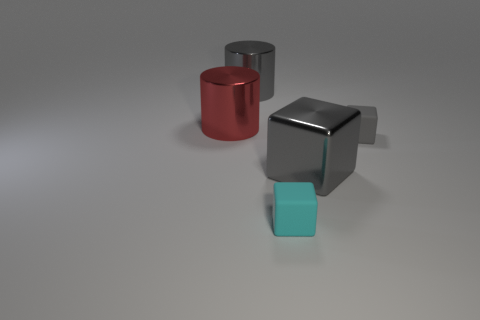Subtract all gray metal cubes. How many cubes are left? 2 Subtract all cyan cubes. How many cubes are left? 2 Subtract all blocks. How many objects are left? 2 Subtract 1 cylinders. How many cylinders are left? 1 Add 1 small cyan matte things. How many objects exist? 6 Subtract all green cubes. How many red cylinders are left? 1 Add 3 red metallic cylinders. How many red metallic cylinders exist? 4 Subtract 0 green cubes. How many objects are left? 5 Subtract all purple cylinders. Subtract all gray balls. How many cylinders are left? 2 Subtract all tiny purple shiny cubes. Subtract all small cyan rubber blocks. How many objects are left? 4 